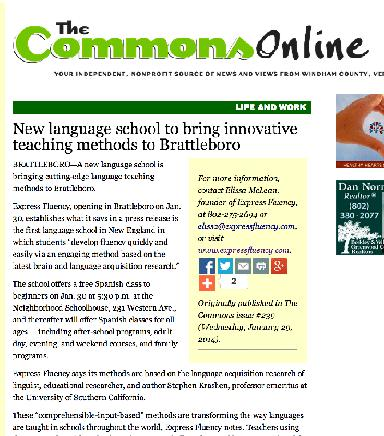Are there any specific facilities or tools mentioned that support the unique teaching methods? The article does not detail specific facilities or tools but emphasizes the use of innovative methods suggested by Krashen's research, which likely implies a focus on interactive and immersive learning environments. 